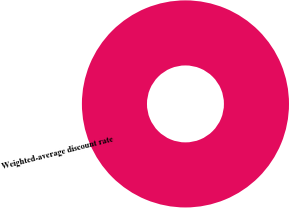Convert chart to OTSL. <chart><loc_0><loc_0><loc_500><loc_500><pie_chart><fcel>Weighted-average discount rate<nl><fcel>100.0%<nl></chart> 